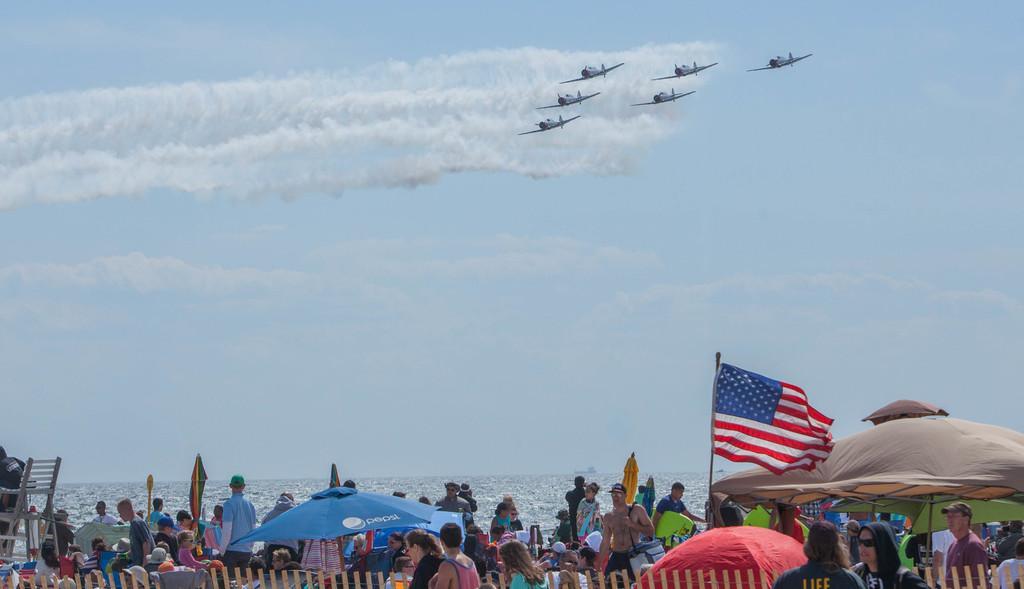How would you summarize this image in a sentence or two? In this image I can see the sky and in the sky I can see few flights flying in the air and I can see a smoke in the air at the bottom I can see few persons visible in front of the ocean and I can see tents and flags at the bottom, in the middle I can see the ocean. 